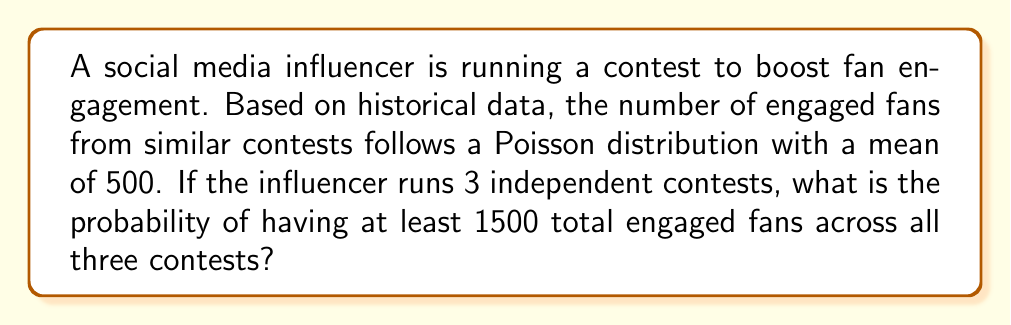Give your solution to this math problem. Let's approach this step-by-step:

1) First, we need to understand that the total number of engaged fans across 3 contests will follow a Poisson distribution with a mean of $3 \times 500 = 1500$. This is because the sum of independent Poisson distributions is also Poisson, with a mean equal to the sum of the individual means.

2) Let $X$ be the total number of engaged fans across 3 contests. Then $X \sim \text{Poisson}(1500)$.

3) We want to find $P(X \geq 1500)$. It's often easier to calculate $P(X < 1500)$ and then subtract from 1:

   $P(X \geq 1500) = 1 - P(X < 1500)$

4) For a Poisson distribution, the cumulative distribution function is given by:

   $P(X < k) = e^{-\lambda} \sum_{i=0}^{k-1} \frac{\lambda^i}{i!}$

   where $\lambda$ is the mean of the distribution.

5) In our case, $\lambda = 1500$ and $k = 1500$. So we need to calculate:

   $P(X < 1500) = e^{-1500} \sum_{i=0}^{1499} \frac{1500^i}{i!}$

6) This is a complex calculation, typically done using software or statistical tables. Using a statistical calculator or software, we get:

   $P(X < 1500) \approx 0.5$

7) Therefore, $P(X \geq 1500) = 1 - P(X < 1500) \approx 1 - 0.5 = 0.5$
Answer: $0.5$ or $50\%$ 